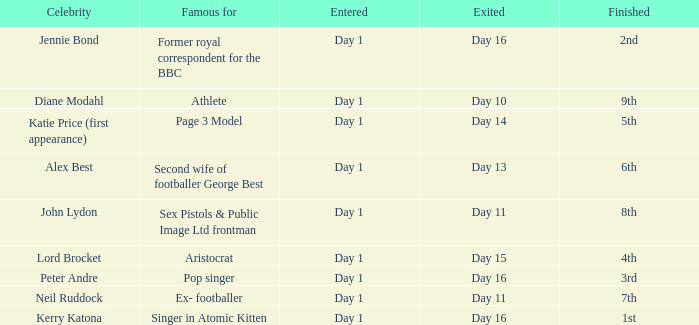Name the entered for famous for page 3 model Day 1. 